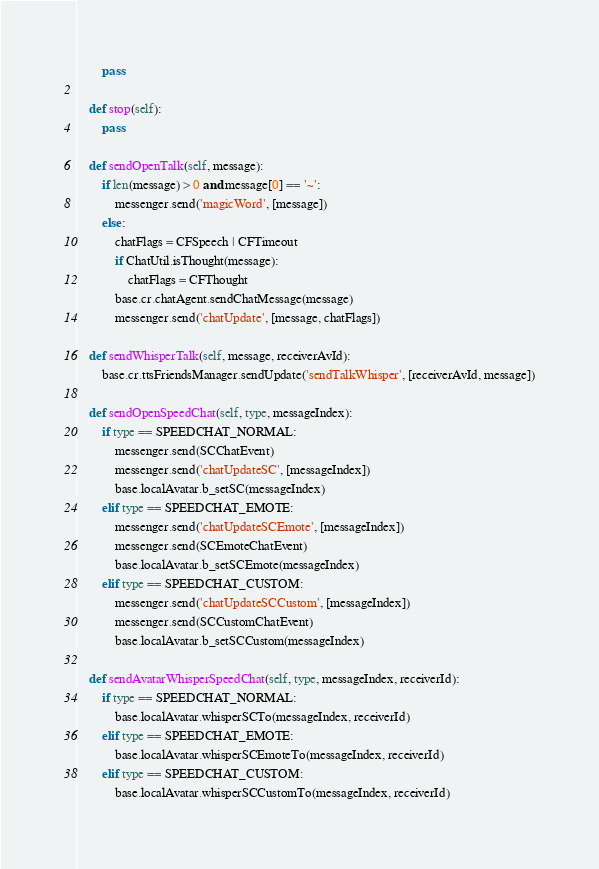<code> <loc_0><loc_0><loc_500><loc_500><_Python_>        pass

    def stop(self):
        pass

    def sendOpenTalk(self, message):
        if len(message) > 0 and message[0] == '~':
            messenger.send('magicWord', [message])
        else:
            chatFlags = CFSpeech | CFTimeout
            if ChatUtil.isThought(message):
                chatFlags = CFThought
            base.cr.chatAgent.sendChatMessage(message)
            messenger.send('chatUpdate', [message, chatFlags])

    def sendWhisperTalk(self, message, receiverAvId):
        base.cr.ttsFriendsManager.sendUpdate('sendTalkWhisper', [receiverAvId, message])

    def sendOpenSpeedChat(self, type, messageIndex):
        if type == SPEEDCHAT_NORMAL:
            messenger.send(SCChatEvent)
            messenger.send('chatUpdateSC', [messageIndex])
            base.localAvatar.b_setSC(messageIndex)
        elif type == SPEEDCHAT_EMOTE:
            messenger.send('chatUpdateSCEmote', [messageIndex])
            messenger.send(SCEmoteChatEvent)
            base.localAvatar.b_setSCEmote(messageIndex)
        elif type == SPEEDCHAT_CUSTOM:
            messenger.send('chatUpdateSCCustom', [messageIndex])
            messenger.send(SCCustomChatEvent)
            base.localAvatar.b_setSCCustom(messageIndex)

    def sendAvatarWhisperSpeedChat(self, type, messageIndex, receiverId):
        if type == SPEEDCHAT_NORMAL:
            base.localAvatar.whisperSCTo(messageIndex, receiverId)
        elif type == SPEEDCHAT_EMOTE:
            base.localAvatar.whisperSCEmoteTo(messageIndex, receiverId)
        elif type == SPEEDCHAT_CUSTOM:
            base.localAvatar.whisperSCCustomTo(messageIndex, receiverId)
</code> 